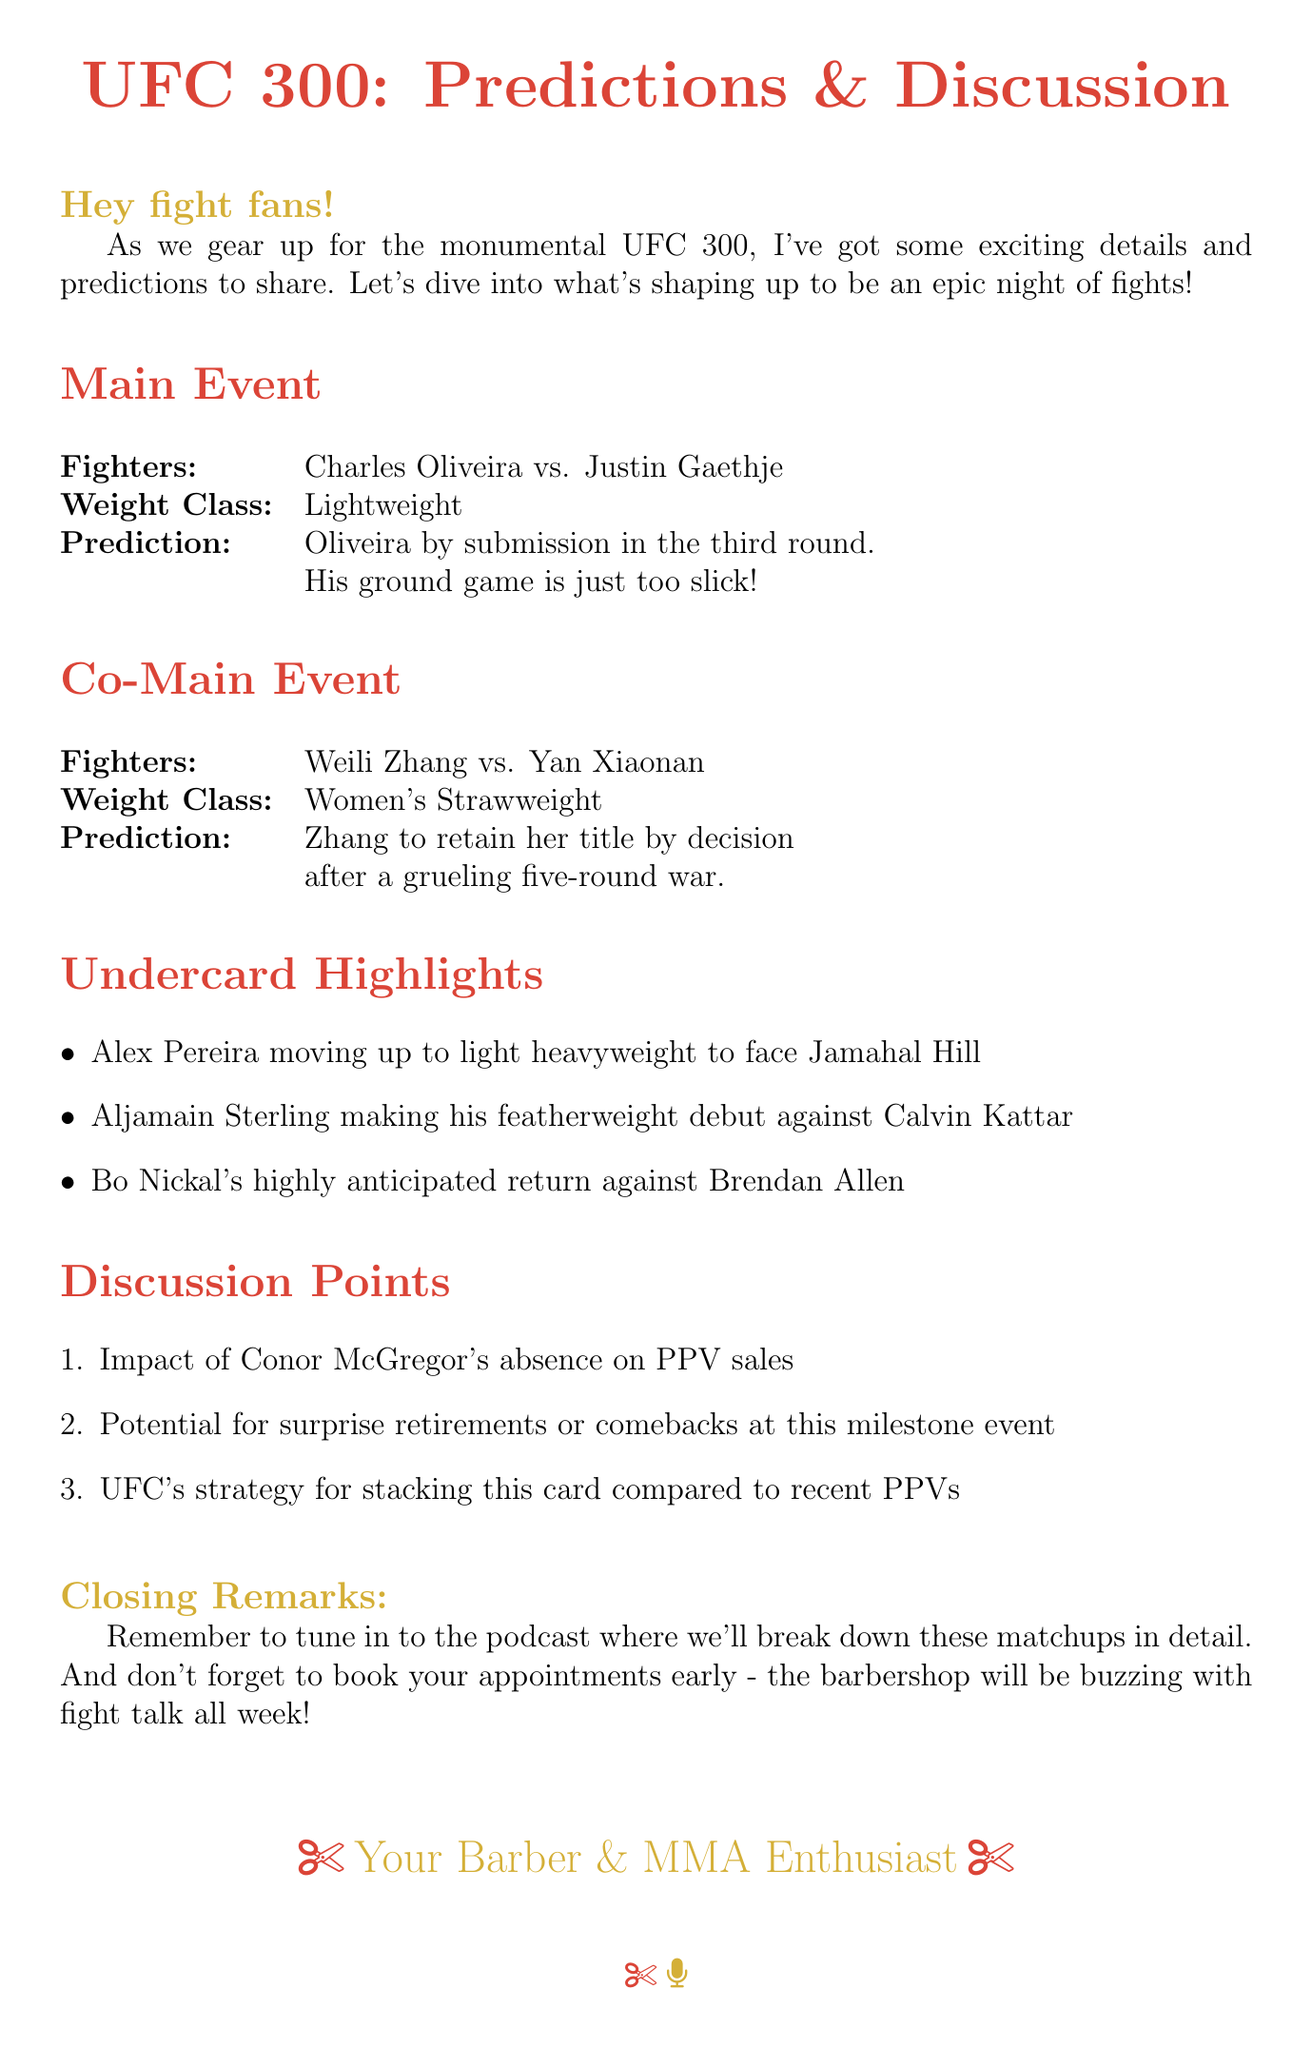What is the main event at UFC 300? The main event features a fight between Charles Oliveira and Justin Gaethje.
Answer: Charles Oliveira vs. Justin Gaethje What is the prediction for the main event? The document states a prediction for the main event, indicating the expected outcome of the fight.
Answer: Oliveira by submission in the third round Who is the co-main event fighters? The co-main event features a match-up between two fighters in the women's strawweight division.
Answer: Weili Zhang vs. Yan Xiaonan What is the prediction for the co-main event? The document includes a prediction about the outcome of the co-main event.
Answer: Zhang to retain her title by decision Which fighter is moving up to light heavyweight? The document mentions a fighter transitioning to a higher weight class for an upcoming match.
Answer: Alex Pereira What are the discussion points mentioned in the email? The document lists several topics that are intended for further discussion regarding UFC 300.
Answer: Impact of Conor McGregor's absence on PPV sales, Potential for surprise retirements or comebacks, UFC's strategy for stacking this card How many rounds is the prediction for the main event? The document specifies the round number related to the prediction for the main event bout.
Answer: Third round What is the significance of UFC 300 discussed in the email? The introduction hints at the profile of the event and its importance in the fight calendar.
Answer: Monumental event Where should listeners tune in for more details? The document provides information on where to find more in-depth coverage on the event.
Answer: The podcast 